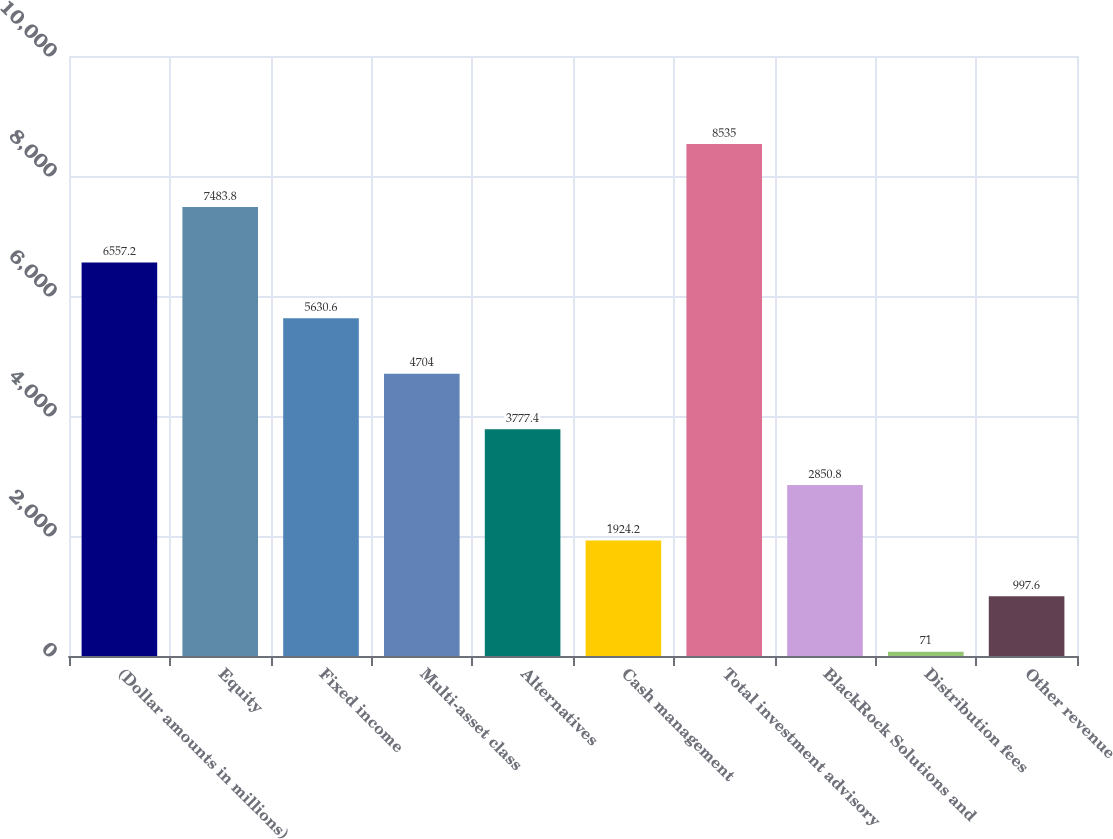<chart> <loc_0><loc_0><loc_500><loc_500><bar_chart><fcel>(Dollar amounts in millions)<fcel>Equity<fcel>Fixed income<fcel>Multi-asset class<fcel>Alternatives<fcel>Cash management<fcel>Total investment advisory<fcel>BlackRock Solutions and<fcel>Distribution fees<fcel>Other revenue<nl><fcel>6557.2<fcel>7483.8<fcel>5630.6<fcel>4704<fcel>3777.4<fcel>1924.2<fcel>8535<fcel>2850.8<fcel>71<fcel>997.6<nl></chart> 